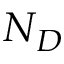Convert formula to latex. <formula><loc_0><loc_0><loc_500><loc_500>N _ { D }</formula> 